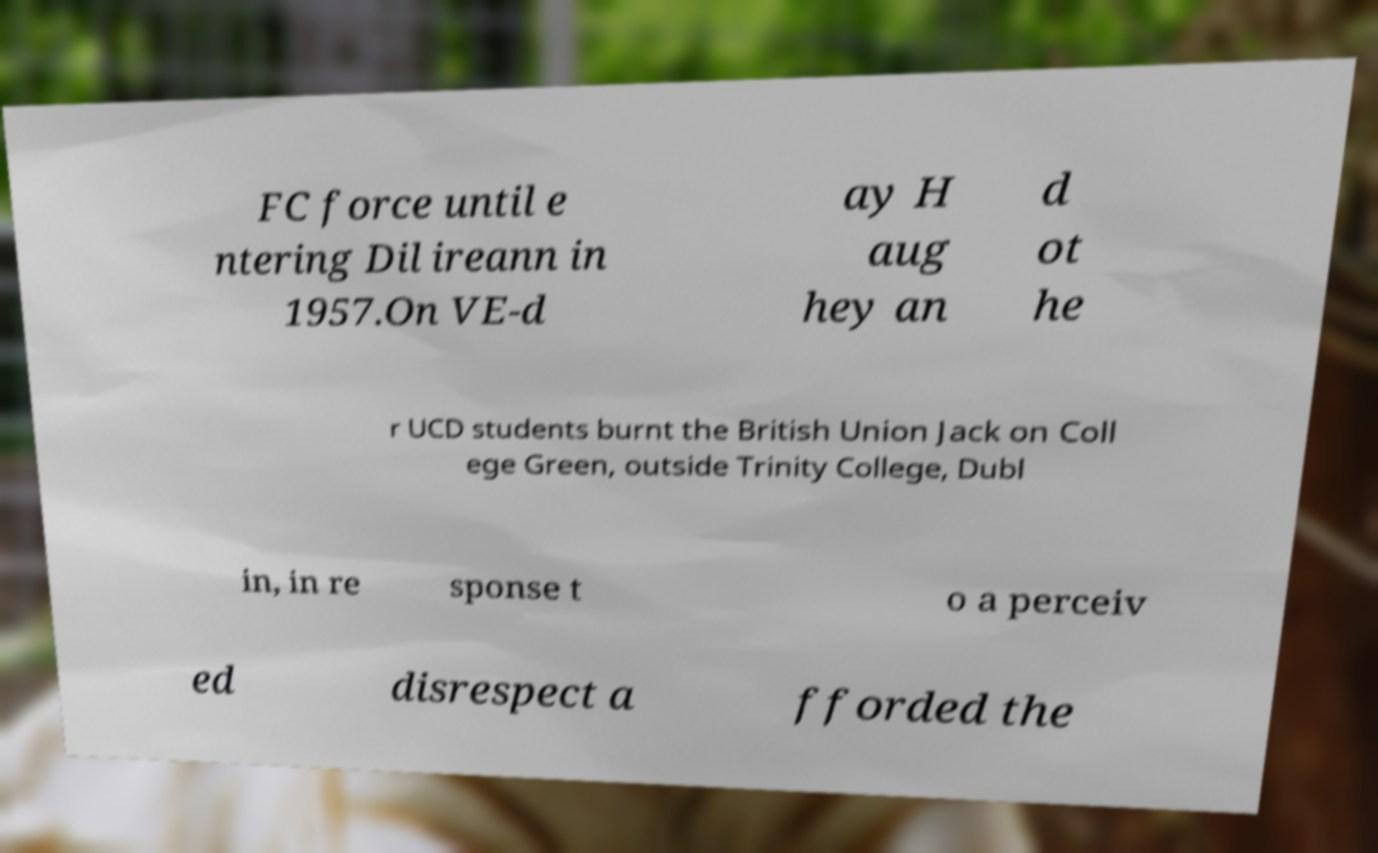I need the written content from this picture converted into text. Can you do that? FC force until e ntering Dil ireann in 1957.On VE-d ay H aug hey an d ot he r UCD students burnt the British Union Jack on Coll ege Green, outside Trinity College, Dubl in, in re sponse t o a perceiv ed disrespect a fforded the 